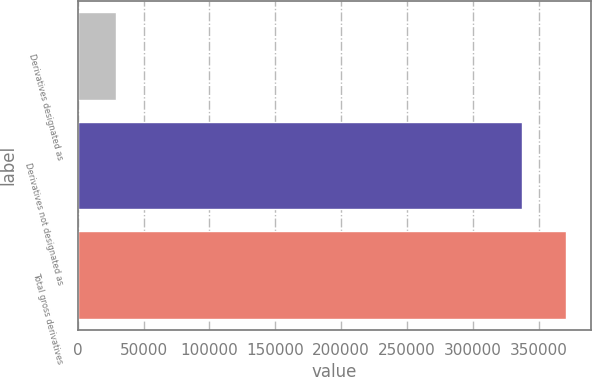Convert chart to OTSL. <chart><loc_0><loc_0><loc_500><loc_500><bar_chart><fcel>Derivatives designated as<fcel>Derivatives not designated as<fcel>Total gross derivatives<nl><fcel>29270<fcel>337086<fcel>370795<nl></chart> 